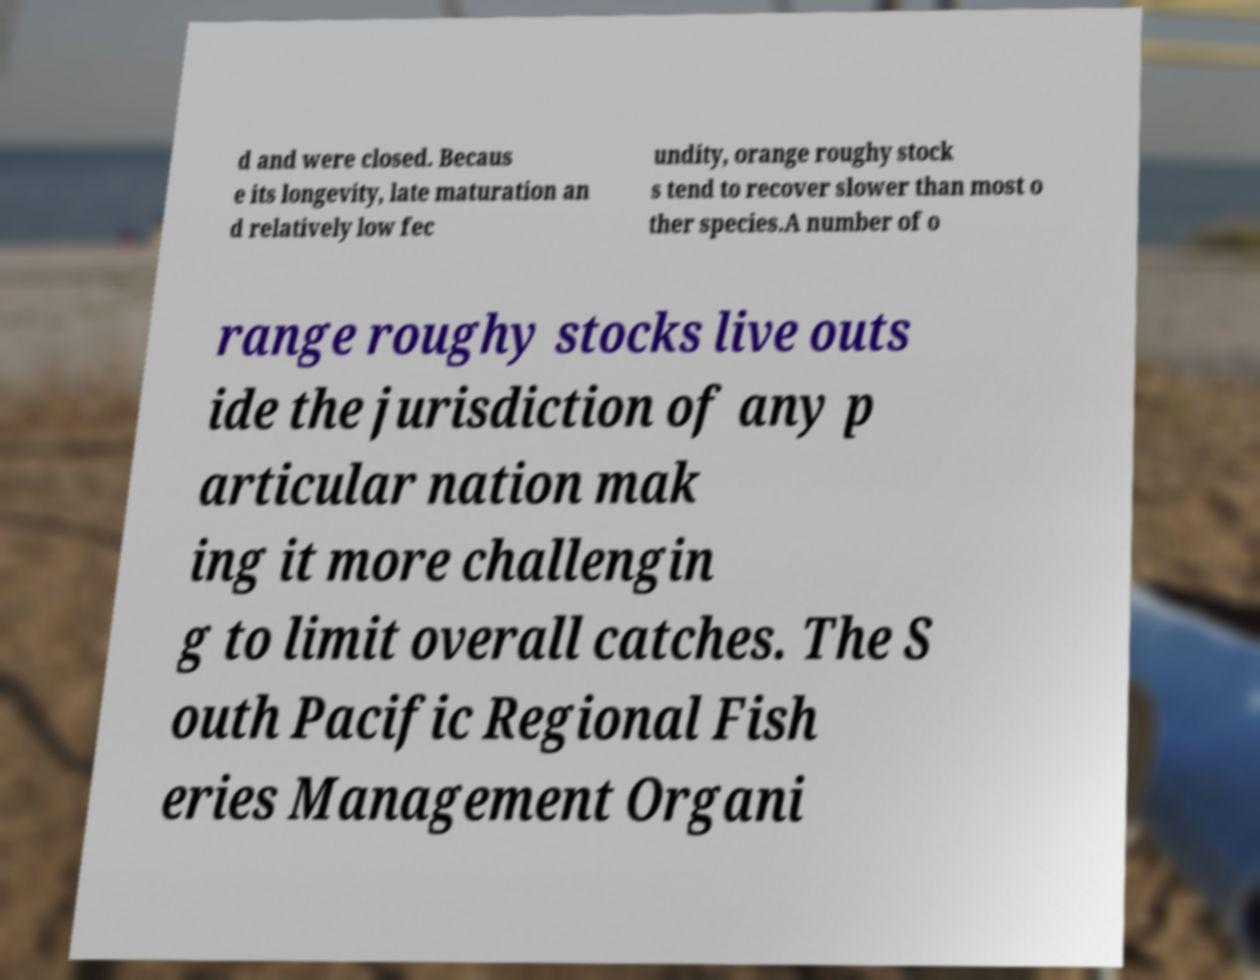There's text embedded in this image that I need extracted. Can you transcribe it verbatim? d and were closed. Becaus e its longevity, late maturation an d relatively low fec undity, orange roughy stock s tend to recover slower than most o ther species.A number of o range roughy stocks live outs ide the jurisdiction of any p articular nation mak ing it more challengin g to limit overall catches. The S outh Pacific Regional Fish eries Management Organi 